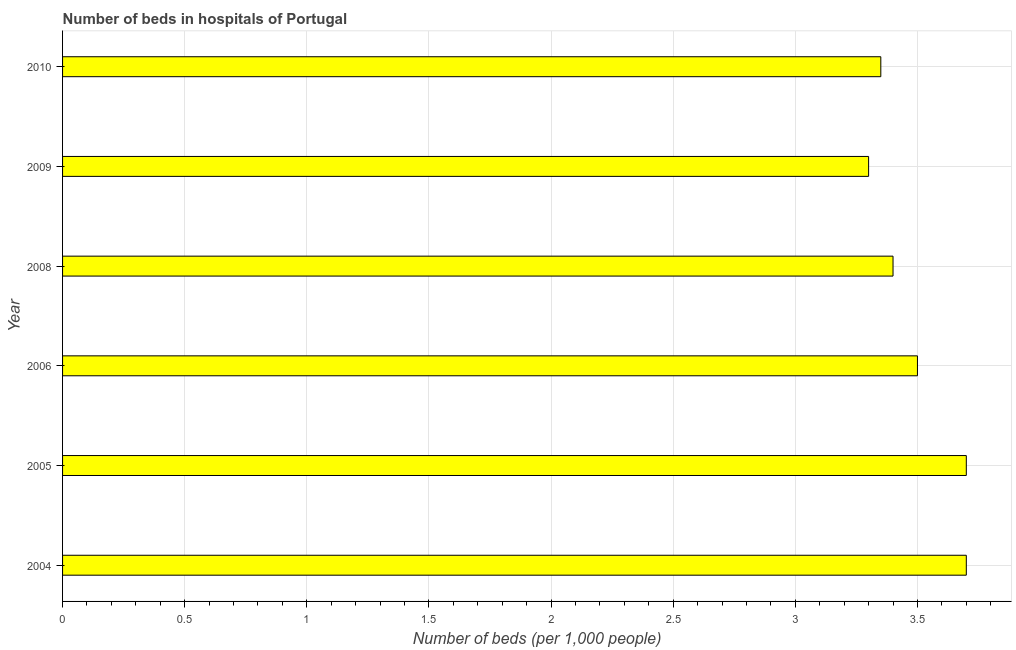Does the graph contain grids?
Provide a succinct answer. Yes. What is the title of the graph?
Give a very brief answer. Number of beds in hospitals of Portugal. What is the label or title of the X-axis?
Ensure brevity in your answer.  Number of beds (per 1,0 people). What is the label or title of the Y-axis?
Offer a terse response. Year. What is the number of hospital beds in 2004?
Make the answer very short. 3.7. Across all years, what is the maximum number of hospital beds?
Your response must be concise. 3.7. Across all years, what is the minimum number of hospital beds?
Provide a succinct answer. 3.3. In which year was the number of hospital beds maximum?
Your answer should be very brief. 2004. What is the sum of the number of hospital beds?
Make the answer very short. 20.95. What is the average number of hospital beds per year?
Keep it short and to the point. 3.49. What is the median number of hospital beds?
Your response must be concise. 3.45. Do a majority of the years between 2009 and 2010 (inclusive) have number of hospital beds greater than 0.3 %?
Offer a terse response. Yes. What is the ratio of the number of hospital beds in 2004 to that in 2009?
Your answer should be very brief. 1.12. Is the number of hospital beds in 2006 less than that in 2009?
Your response must be concise. No. Is the difference between the number of hospital beds in 2004 and 2005 greater than the difference between any two years?
Provide a succinct answer. No. What is the difference between the highest and the second highest number of hospital beds?
Give a very brief answer. 0. What is the difference between the highest and the lowest number of hospital beds?
Offer a very short reply. 0.4. In how many years, is the number of hospital beds greater than the average number of hospital beds taken over all years?
Ensure brevity in your answer.  3. Are all the bars in the graph horizontal?
Your response must be concise. Yes. Are the values on the major ticks of X-axis written in scientific E-notation?
Your answer should be compact. No. What is the Number of beds (per 1,000 people) of 2008?
Provide a succinct answer. 3.4. What is the Number of beds (per 1,000 people) in 2009?
Your response must be concise. 3.3. What is the Number of beds (per 1,000 people) of 2010?
Make the answer very short. 3.35. What is the difference between the Number of beds (per 1,000 people) in 2004 and 2005?
Offer a terse response. 0. What is the difference between the Number of beds (per 1,000 people) in 2004 and 2006?
Your answer should be very brief. 0.2. What is the difference between the Number of beds (per 1,000 people) in 2004 and 2009?
Your answer should be compact. 0.4. What is the difference between the Number of beds (per 1,000 people) in 2004 and 2010?
Your response must be concise. 0.35. What is the difference between the Number of beds (per 1,000 people) in 2005 and 2009?
Your response must be concise. 0.4. What is the difference between the Number of beds (per 1,000 people) in 2005 and 2010?
Keep it short and to the point. 0.35. What is the difference between the Number of beds (per 1,000 people) in 2006 and 2008?
Make the answer very short. 0.1. What is the difference between the Number of beds (per 1,000 people) in 2006 and 2009?
Offer a very short reply. 0.2. What is the difference between the Number of beds (per 1,000 people) in 2006 and 2010?
Your answer should be compact. 0.15. What is the difference between the Number of beds (per 1,000 people) in 2008 and 2009?
Give a very brief answer. 0.1. What is the difference between the Number of beds (per 1,000 people) in 2008 and 2010?
Your answer should be very brief. 0.05. What is the difference between the Number of beds (per 1,000 people) in 2009 and 2010?
Provide a short and direct response. -0.05. What is the ratio of the Number of beds (per 1,000 people) in 2004 to that in 2006?
Give a very brief answer. 1.06. What is the ratio of the Number of beds (per 1,000 people) in 2004 to that in 2008?
Offer a very short reply. 1.09. What is the ratio of the Number of beds (per 1,000 people) in 2004 to that in 2009?
Provide a short and direct response. 1.12. What is the ratio of the Number of beds (per 1,000 people) in 2004 to that in 2010?
Make the answer very short. 1.1. What is the ratio of the Number of beds (per 1,000 people) in 2005 to that in 2006?
Make the answer very short. 1.06. What is the ratio of the Number of beds (per 1,000 people) in 2005 to that in 2008?
Your response must be concise. 1.09. What is the ratio of the Number of beds (per 1,000 people) in 2005 to that in 2009?
Provide a short and direct response. 1.12. What is the ratio of the Number of beds (per 1,000 people) in 2005 to that in 2010?
Offer a very short reply. 1.1. What is the ratio of the Number of beds (per 1,000 people) in 2006 to that in 2008?
Your answer should be compact. 1.03. What is the ratio of the Number of beds (per 1,000 people) in 2006 to that in 2009?
Make the answer very short. 1.06. What is the ratio of the Number of beds (per 1,000 people) in 2006 to that in 2010?
Ensure brevity in your answer.  1.04. What is the ratio of the Number of beds (per 1,000 people) in 2008 to that in 2009?
Make the answer very short. 1.03. What is the ratio of the Number of beds (per 1,000 people) in 2008 to that in 2010?
Keep it short and to the point. 1.01. What is the ratio of the Number of beds (per 1,000 people) in 2009 to that in 2010?
Your response must be concise. 0.98. 